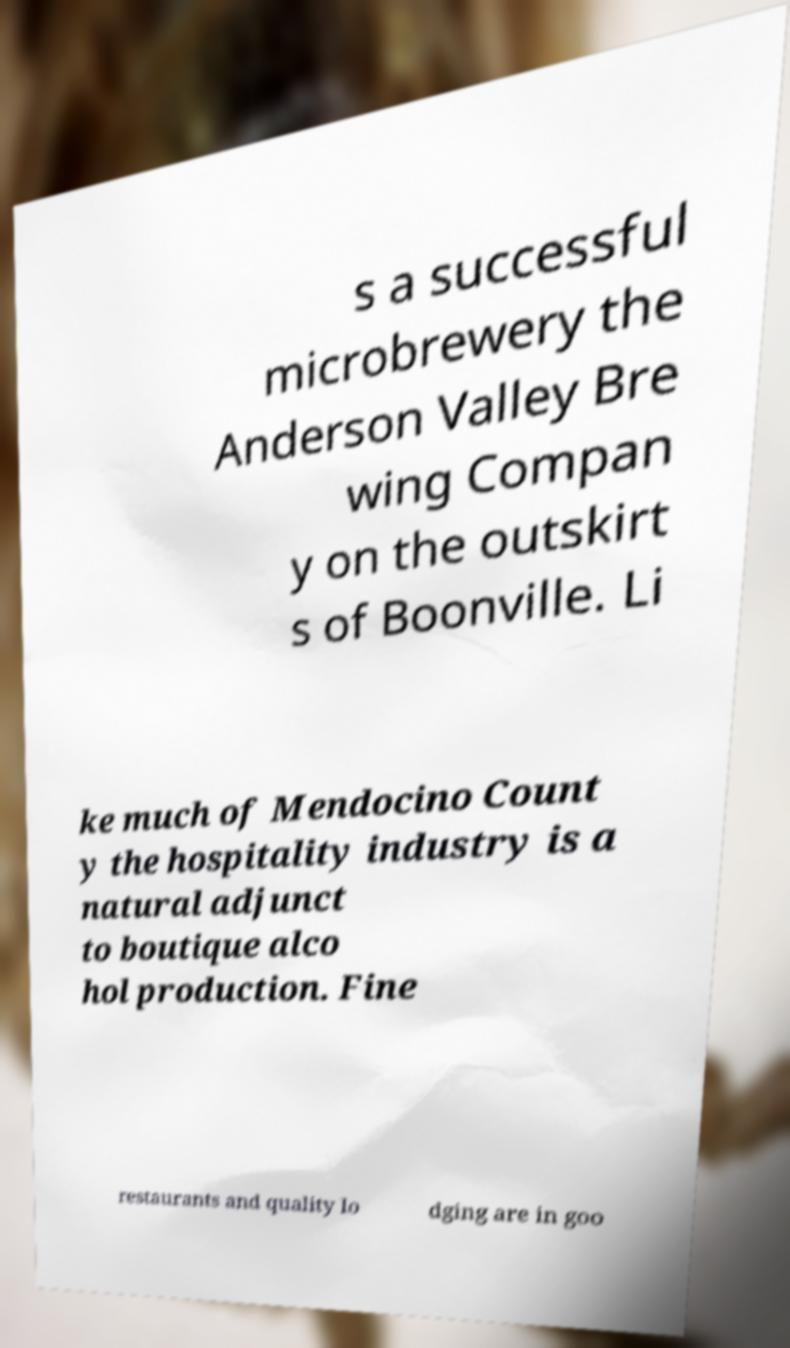Please read and relay the text visible in this image. What does it say? s a successful microbrewery the Anderson Valley Bre wing Compan y on the outskirt s of Boonville. Li ke much of Mendocino Count y the hospitality industry is a natural adjunct to boutique alco hol production. Fine restaurants and quality lo dging are in goo 